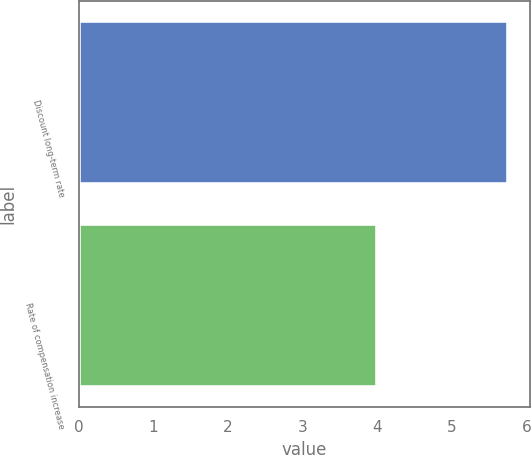Convert chart. <chart><loc_0><loc_0><loc_500><loc_500><bar_chart><fcel>Discount long-term rate<fcel>Rate of compensation increase<nl><fcel>5.75<fcel>4<nl></chart> 